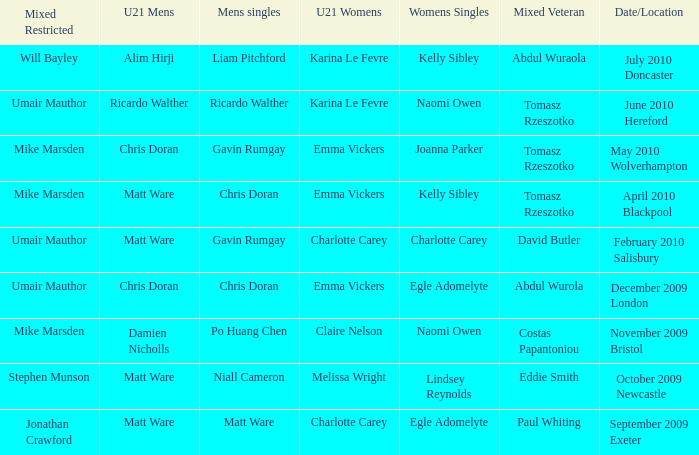When and where did Eddie Smith win the mixed veteran? 1.0. 